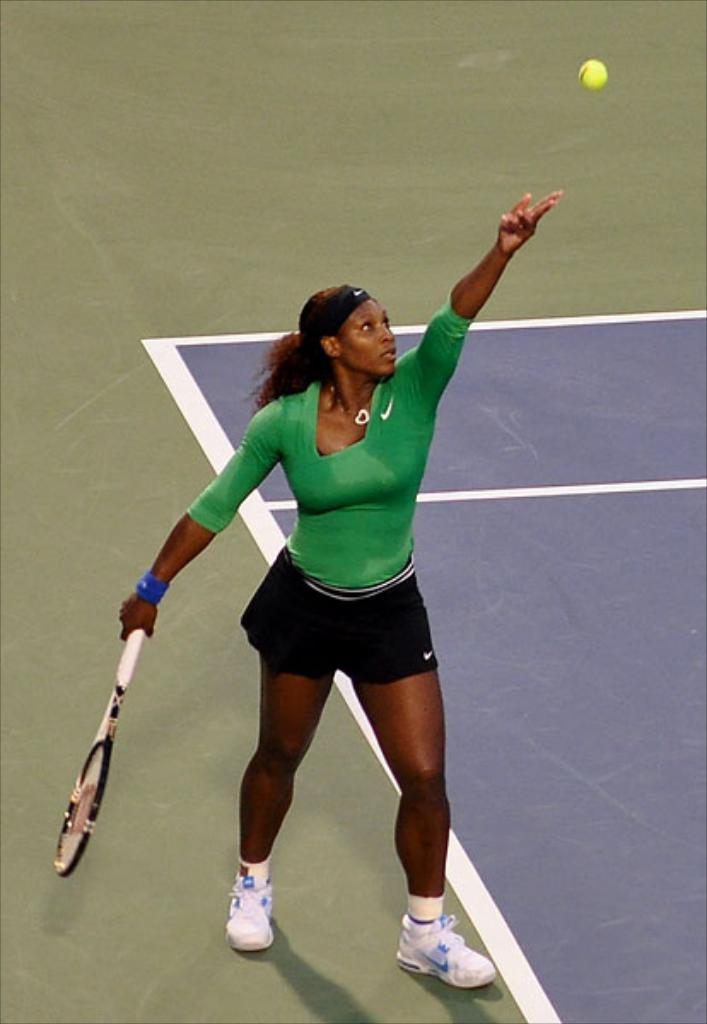Who is the main subject in the image? Serena Williams is in the image. What is Serena Williams doing in the image? Serena Williams is serving a tennis ball in the image. What type of cable can be seen in the image? There is no cable present in the image. What is Serena Williams's grandmother doing in the image? There is no mention of Serena Williams's grandmother in the image or the provided facts. 